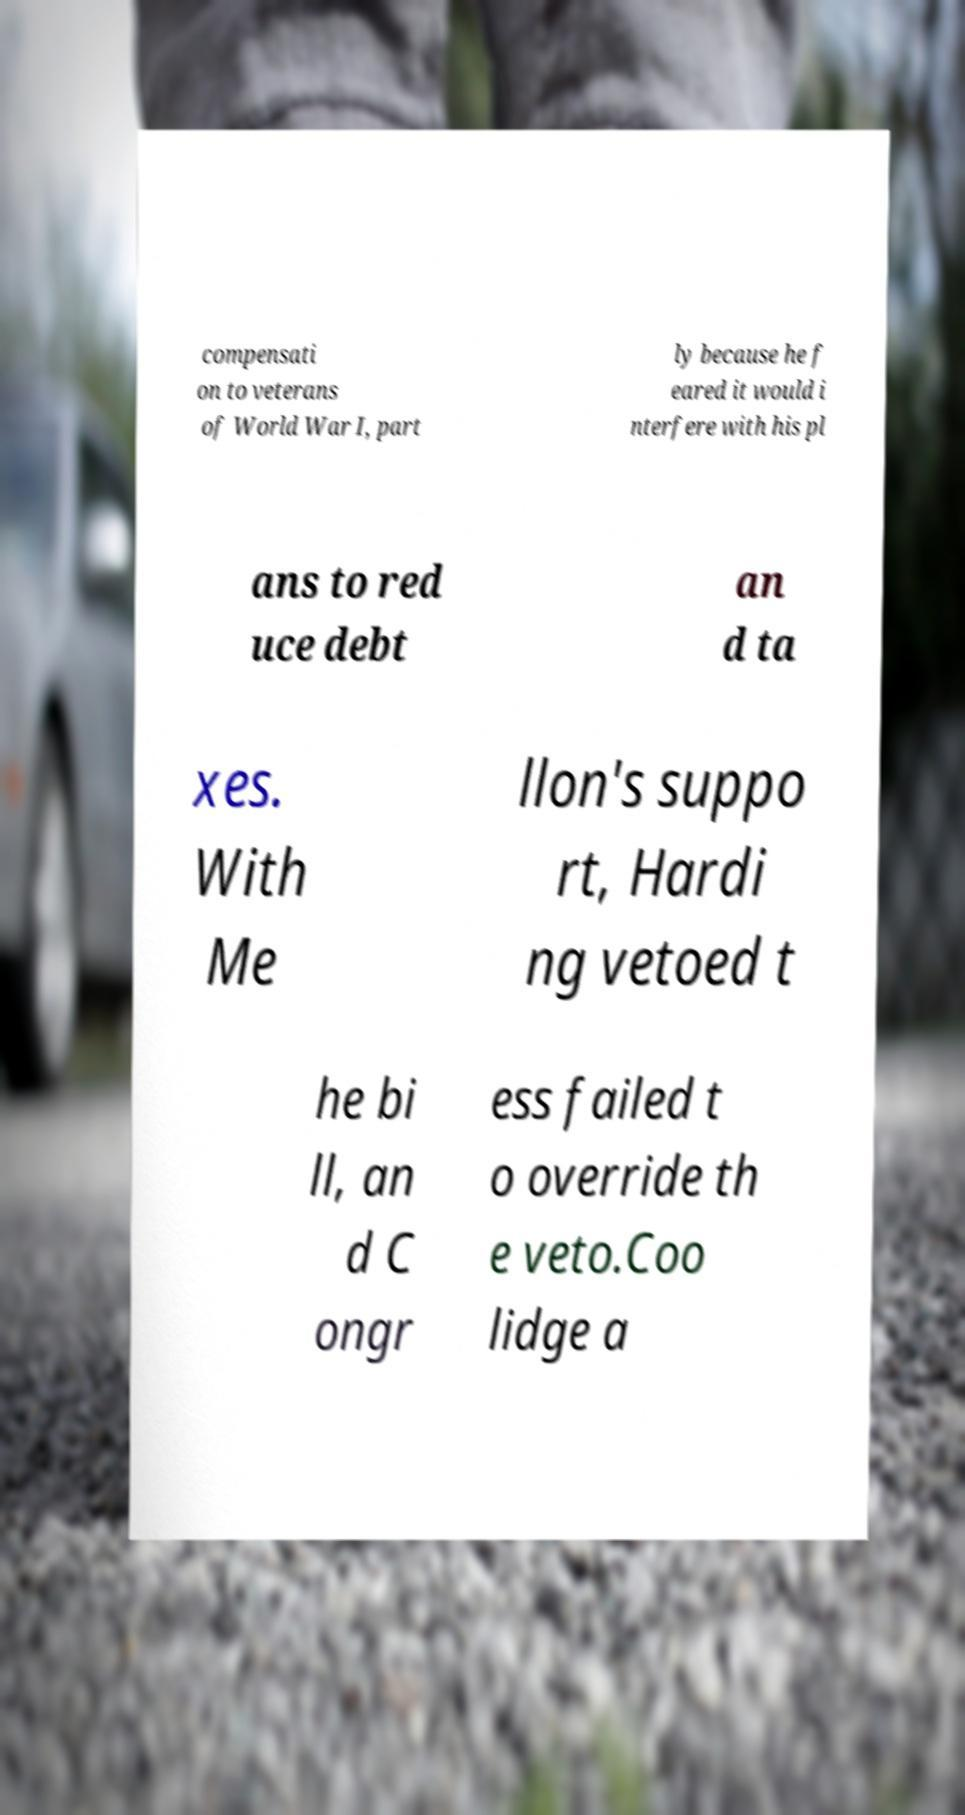Could you assist in decoding the text presented in this image and type it out clearly? compensati on to veterans of World War I, part ly because he f eared it would i nterfere with his pl ans to red uce debt an d ta xes. With Me llon's suppo rt, Hardi ng vetoed t he bi ll, an d C ongr ess failed t o override th e veto.Coo lidge a 